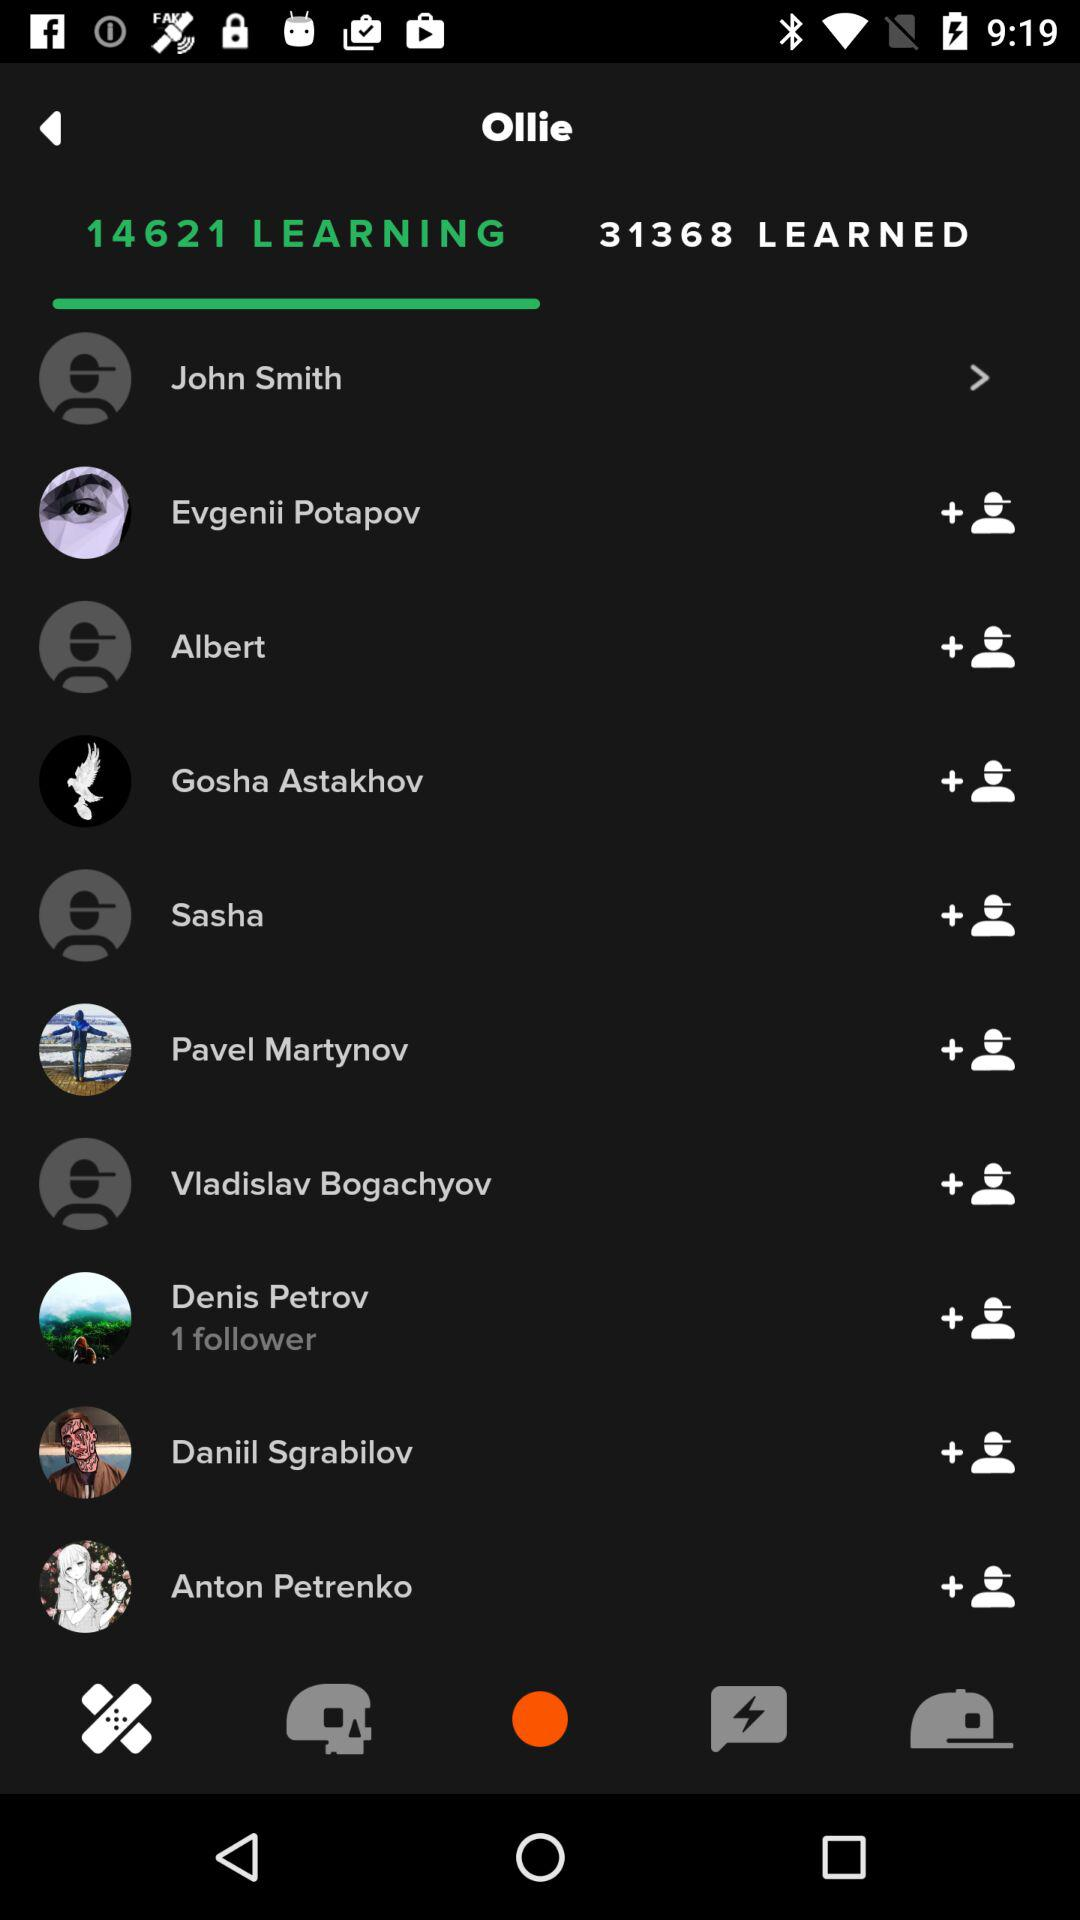What is the current number of people who are still learning? The current number of people who are still learning is 14621. 